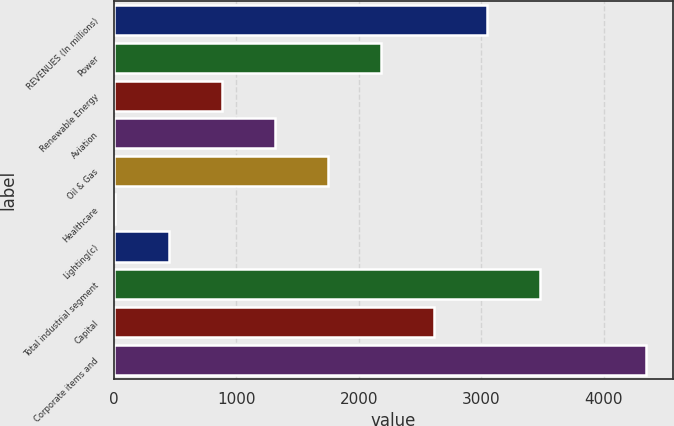Convert chart to OTSL. <chart><loc_0><loc_0><loc_500><loc_500><bar_chart><fcel>REVENUES (In millions)<fcel>Power<fcel>Renewable Energy<fcel>Aviation<fcel>Oil & Gas<fcel>Healthcare<fcel>Lighting(c)<fcel>Total industrial segment<fcel>Capital<fcel>Corporate items and<nl><fcel>3046<fcel>2180<fcel>881<fcel>1314<fcel>1747<fcel>15<fcel>448<fcel>3479<fcel>2613<fcel>4345<nl></chart> 